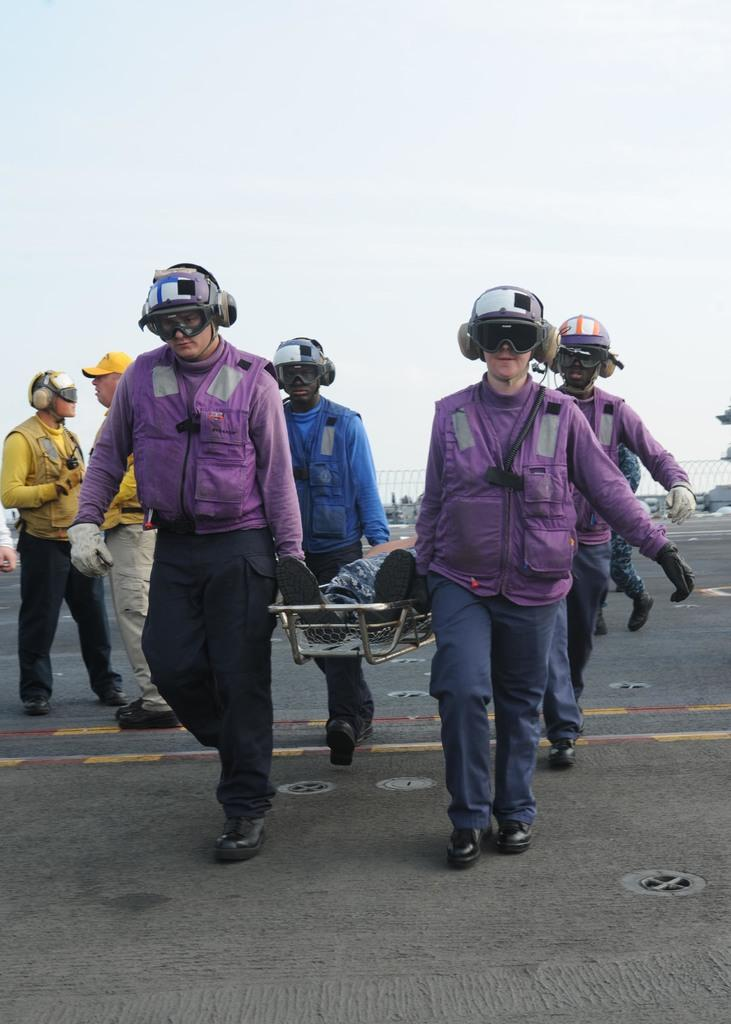What is the main subject of the image? There is a person lying on a stretcher in the image. Who is assisting the person on the stretcher? Four people are carrying the stretcher. Are there any other people in the image? Yes, there are two people standing. What can be seen in the background of the image? There is a road and the sky visible in the image. What type of riddle is being exchanged between the two standing people in the image? There is no indication in the image that a riddle is being exchanged between the two standing people. What type of amusement can be seen in the image? There is no amusement present in the image; it depicts a person on a stretcher being carried by four people. 